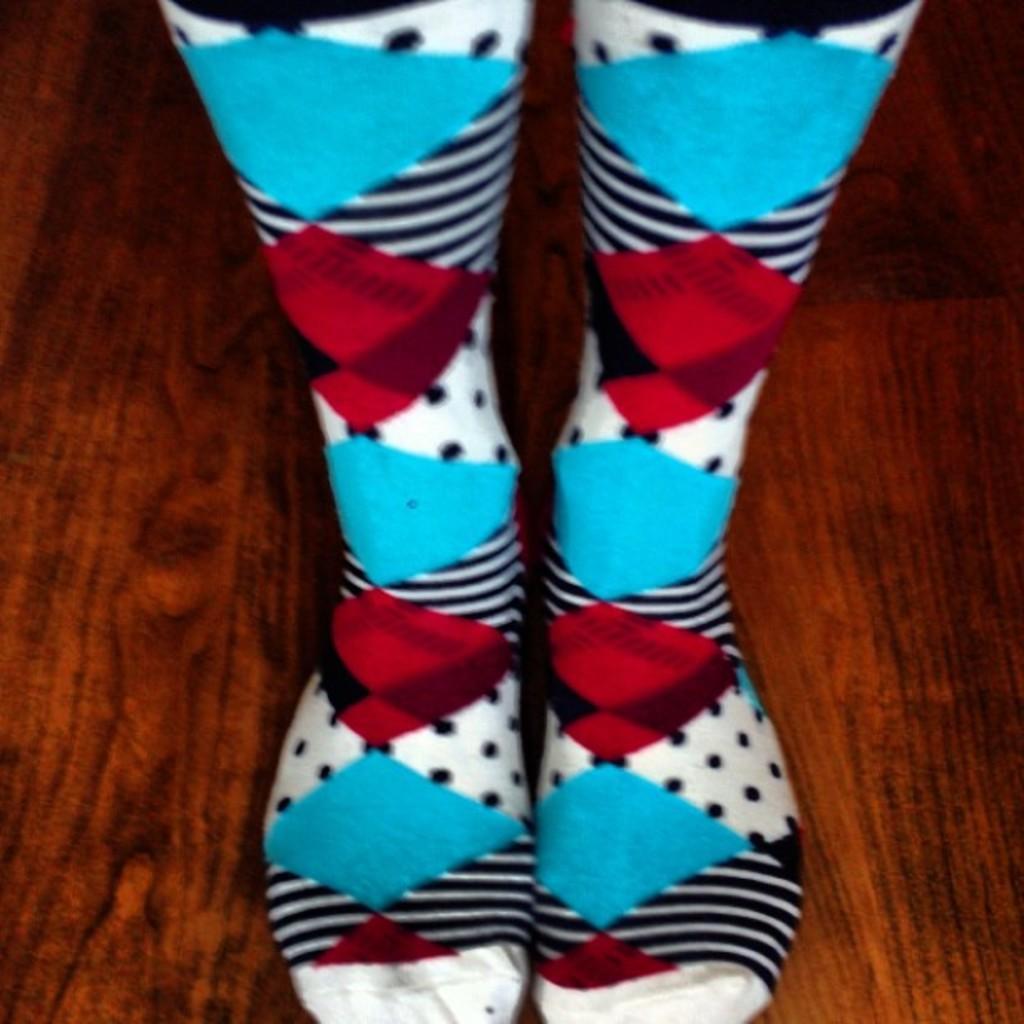How would you summarize this image in a sentence or two? In this picture I can see legs with socks and I can see floor. 